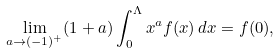<formula> <loc_0><loc_0><loc_500><loc_500>\lim _ { a \rightarrow ( - 1 ) ^ { + } } ( 1 + a ) \int _ { 0 } ^ { \Lambda } x ^ { a } f ( x ) \, d x = f ( 0 ) ,</formula> 